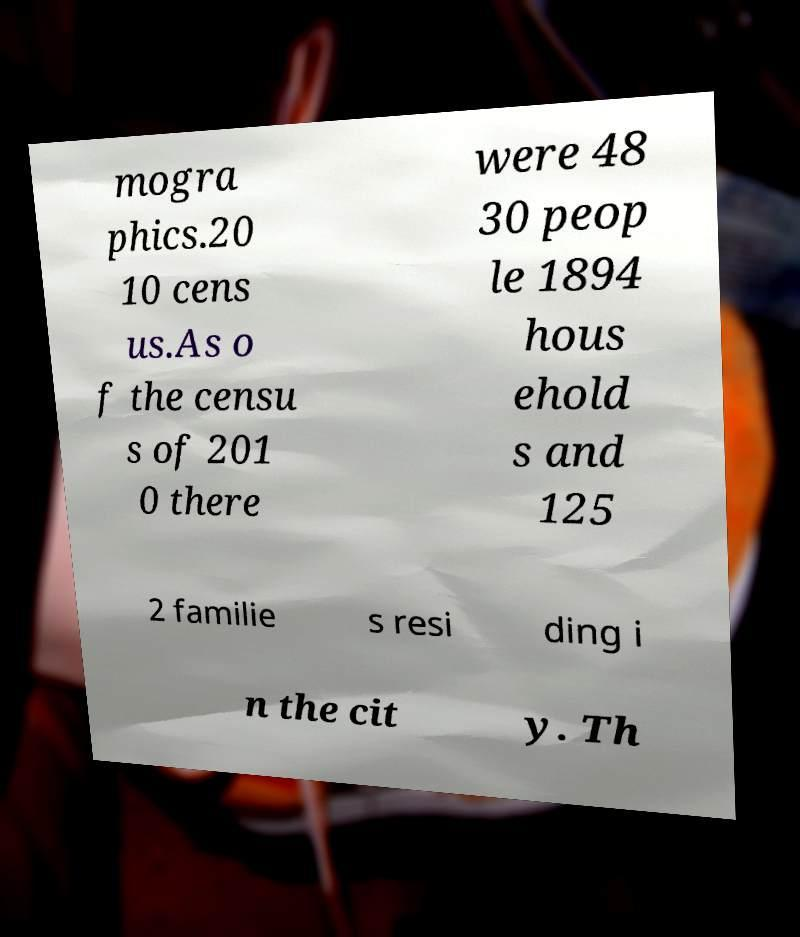Could you extract and type out the text from this image? mogra phics.20 10 cens us.As o f the censu s of 201 0 there were 48 30 peop le 1894 hous ehold s and 125 2 familie s resi ding i n the cit y. Th 